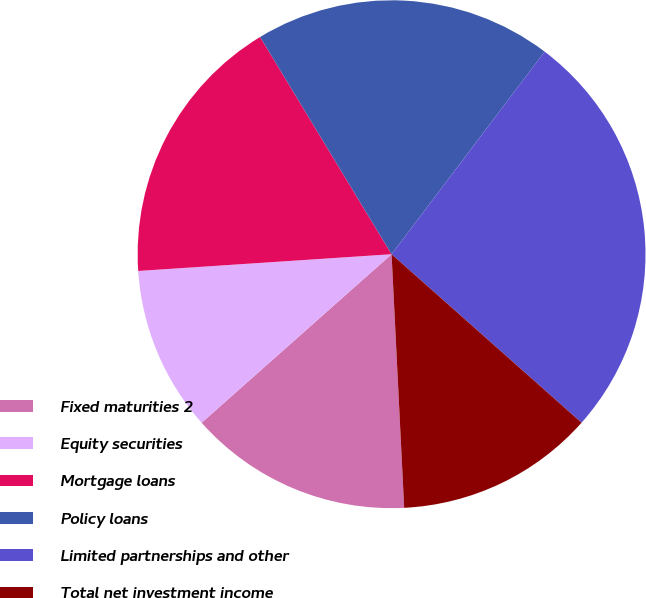Convert chart. <chart><loc_0><loc_0><loc_500><loc_500><pie_chart><fcel>Fixed maturities 2<fcel>Equity securities<fcel>Mortgage loans<fcel>Policy loans<fcel>Limited partnerships and other<fcel>Total net investment income<nl><fcel>14.24%<fcel>10.5%<fcel>17.39%<fcel>18.96%<fcel>26.25%<fcel>12.66%<nl></chart> 